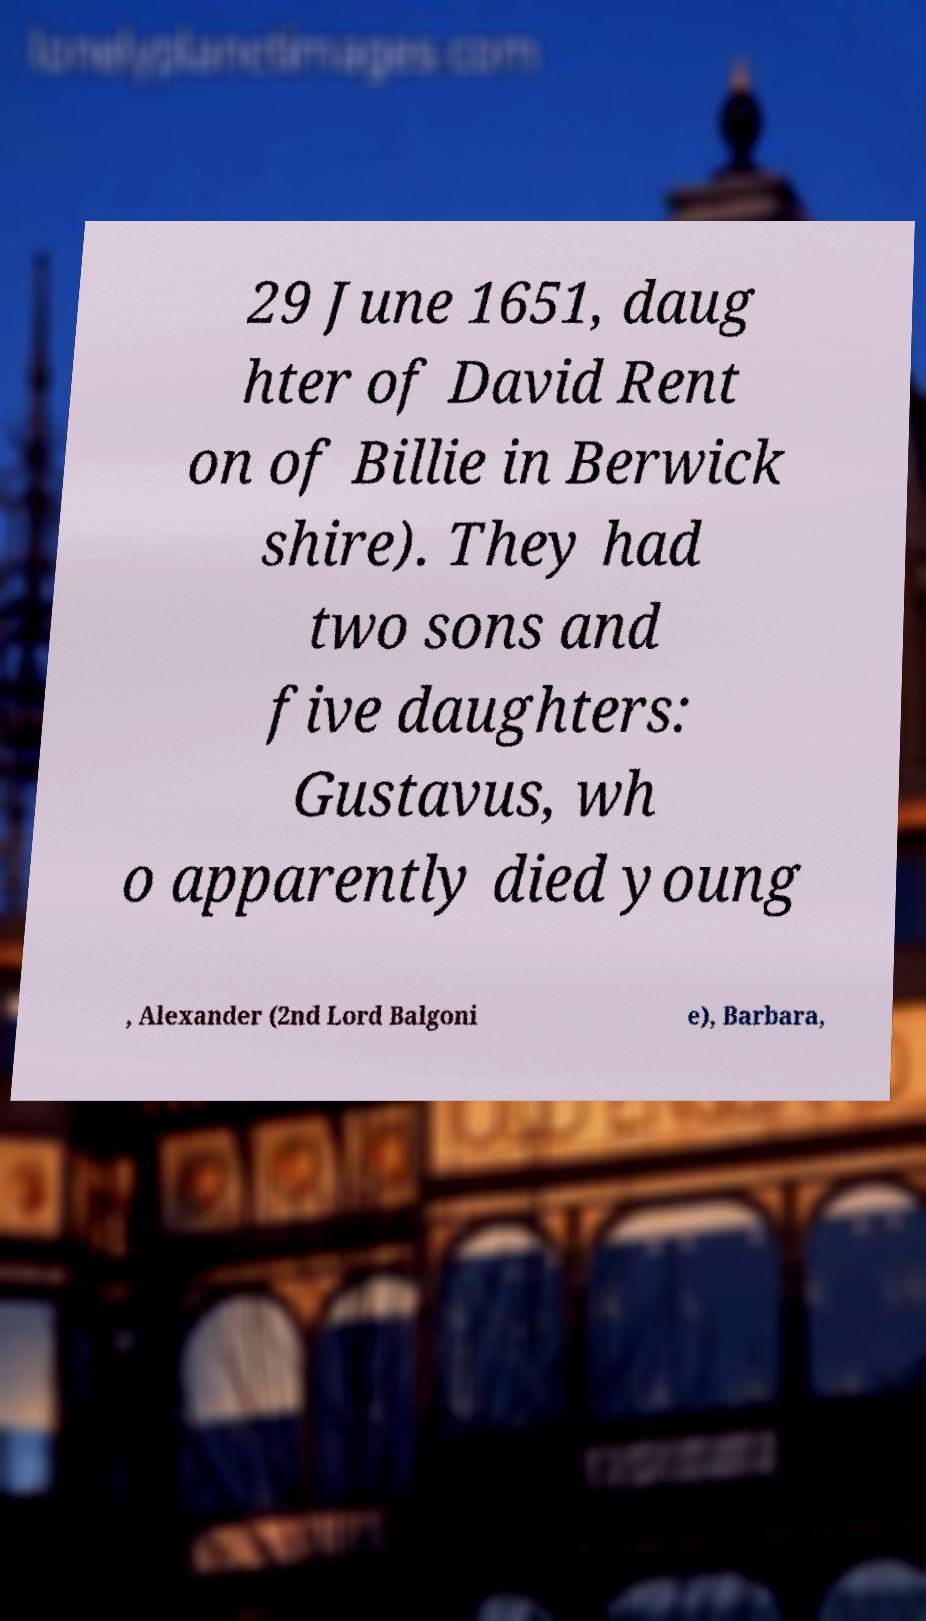Could you extract and type out the text from this image? 29 June 1651, daug hter of David Rent on of Billie in Berwick shire). They had two sons and five daughters: Gustavus, wh o apparently died young , Alexander (2nd Lord Balgoni e), Barbara, 